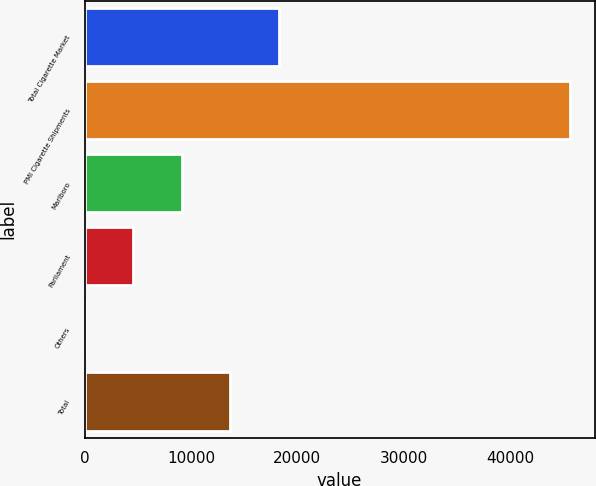Convert chart to OTSL. <chart><loc_0><loc_0><loc_500><loc_500><bar_chart><fcel>Total Cigarette Market<fcel>PMI Cigarette Shipments<fcel>Marlboro<fcel>Parliament<fcel>Others<fcel>Total<nl><fcel>18277.1<fcel>45690<fcel>9139.44<fcel>4570.62<fcel>1.8<fcel>13708.3<nl></chart> 